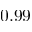Convert formula to latex. <formula><loc_0><loc_0><loc_500><loc_500>0 . 9 9</formula> 